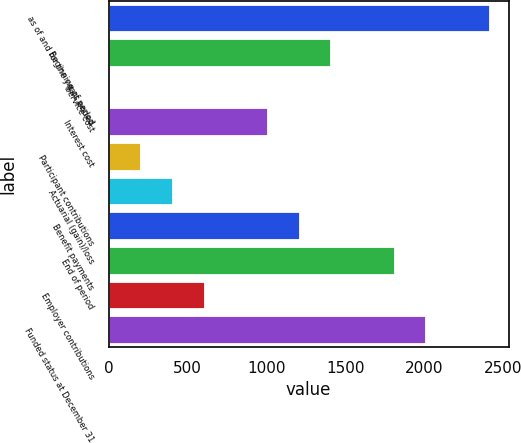<chart> <loc_0><loc_0><loc_500><loc_500><bar_chart><fcel>as of and for the years ended<fcel>Beginning of period<fcel>Service cost<fcel>Interest cost<fcel>Participant contributions<fcel>Actuarial (gain)/loss<fcel>Benefit payments<fcel>End of period<fcel>Employer contributions<fcel>Funded status at December 31<nl><fcel>2413<fcel>1410.5<fcel>7<fcel>1009.5<fcel>207.5<fcel>408<fcel>1210<fcel>1811.5<fcel>608.5<fcel>2012<nl></chart> 